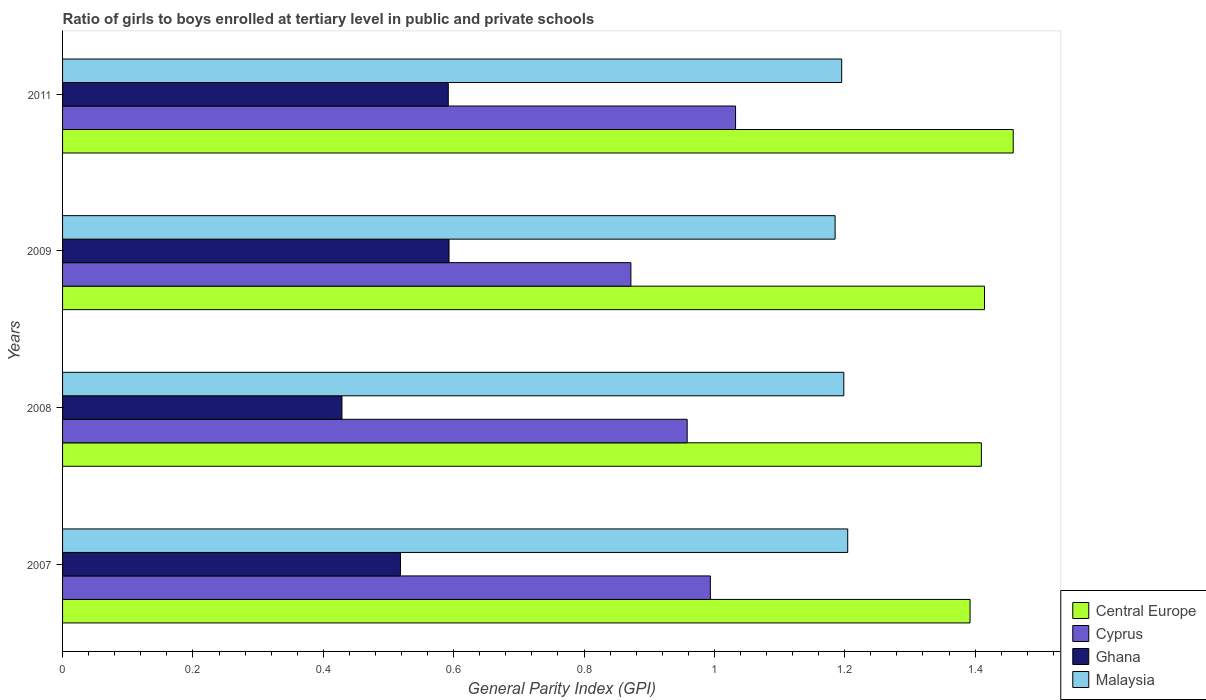How many different coloured bars are there?
Give a very brief answer. 4. How many groups of bars are there?
Offer a very short reply. 4. Are the number of bars per tick equal to the number of legend labels?
Your response must be concise. Yes. In how many cases, is the number of bars for a given year not equal to the number of legend labels?
Provide a short and direct response. 0. What is the general parity index in Ghana in 2009?
Provide a short and direct response. 0.59. Across all years, what is the maximum general parity index in Cyprus?
Provide a short and direct response. 1.03. Across all years, what is the minimum general parity index in Central Europe?
Provide a short and direct response. 1.39. What is the total general parity index in Malaysia in the graph?
Your answer should be compact. 4.78. What is the difference between the general parity index in Ghana in 2007 and that in 2009?
Your response must be concise. -0.07. What is the difference between the general parity index in Central Europe in 2009 and the general parity index in Malaysia in 2007?
Provide a short and direct response. 0.21. What is the average general parity index in Malaysia per year?
Keep it short and to the point. 1.2. In the year 2008, what is the difference between the general parity index in Cyprus and general parity index in Central Europe?
Make the answer very short. -0.45. In how many years, is the general parity index in Cyprus greater than 0.12 ?
Ensure brevity in your answer.  4. What is the ratio of the general parity index in Malaysia in 2007 to that in 2011?
Give a very brief answer. 1.01. What is the difference between the highest and the second highest general parity index in Central Europe?
Offer a very short reply. 0.04. What is the difference between the highest and the lowest general parity index in Cyprus?
Provide a short and direct response. 0.16. Is the sum of the general parity index in Malaysia in 2008 and 2011 greater than the maximum general parity index in Central Europe across all years?
Your answer should be very brief. Yes. What does the 4th bar from the top in 2008 represents?
Your answer should be very brief. Central Europe. What does the 4th bar from the bottom in 2009 represents?
Ensure brevity in your answer.  Malaysia. Is it the case that in every year, the sum of the general parity index in Ghana and general parity index in Malaysia is greater than the general parity index in Cyprus?
Your response must be concise. Yes. How many bars are there?
Your answer should be very brief. 16. Are all the bars in the graph horizontal?
Your answer should be very brief. Yes. How many years are there in the graph?
Offer a very short reply. 4. What is the difference between two consecutive major ticks on the X-axis?
Give a very brief answer. 0.2. Are the values on the major ticks of X-axis written in scientific E-notation?
Your answer should be compact. No. Where does the legend appear in the graph?
Your response must be concise. Bottom right. How many legend labels are there?
Provide a short and direct response. 4. What is the title of the graph?
Your answer should be compact. Ratio of girls to boys enrolled at tertiary level in public and private schools. What is the label or title of the X-axis?
Provide a succinct answer. General Parity Index (GPI). What is the label or title of the Y-axis?
Your answer should be very brief. Years. What is the General Parity Index (GPI) in Central Europe in 2007?
Make the answer very short. 1.39. What is the General Parity Index (GPI) in Cyprus in 2007?
Give a very brief answer. 0.99. What is the General Parity Index (GPI) in Ghana in 2007?
Offer a very short reply. 0.52. What is the General Parity Index (GPI) of Malaysia in 2007?
Give a very brief answer. 1.2. What is the General Parity Index (GPI) in Central Europe in 2008?
Provide a succinct answer. 1.41. What is the General Parity Index (GPI) of Cyprus in 2008?
Your response must be concise. 0.96. What is the General Parity Index (GPI) of Ghana in 2008?
Your answer should be very brief. 0.43. What is the General Parity Index (GPI) in Malaysia in 2008?
Your answer should be very brief. 1.2. What is the General Parity Index (GPI) of Central Europe in 2009?
Ensure brevity in your answer.  1.41. What is the General Parity Index (GPI) of Cyprus in 2009?
Keep it short and to the point. 0.87. What is the General Parity Index (GPI) of Ghana in 2009?
Offer a terse response. 0.59. What is the General Parity Index (GPI) of Malaysia in 2009?
Your answer should be very brief. 1.19. What is the General Parity Index (GPI) of Central Europe in 2011?
Provide a short and direct response. 1.46. What is the General Parity Index (GPI) in Cyprus in 2011?
Give a very brief answer. 1.03. What is the General Parity Index (GPI) in Ghana in 2011?
Give a very brief answer. 0.59. What is the General Parity Index (GPI) in Malaysia in 2011?
Provide a short and direct response. 1.2. Across all years, what is the maximum General Parity Index (GPI) in Central Europe?
Offer a very short reply. 1.46. Across all years, what is the maximum General Parity Index (GPI) of Cyprus?
Make the answer very short. 1.03. Across all years, what is the maximum General Parity Index (GPI) of Ghana?
Provide a short and direct response. 0.59. Across all years, what is the maximum General Parity Index (GPI) in Malaysia?
Your answer should be very brief. 1.2. Across all years, what is the minimum General Parity Index (GPI) in Central Europe?
Offer a terse response. 1.39. Across all years, what is the minimum General Parity Index (GPI) of Cyprus?
Your response must be concise. 0.87. Across all years, what is the minimum General Parity Index (GPI) in Ghana?
Provide a short and direct response. 0.43. Across all years, what is the minimum General Parity Index (GPI) in Malaysia?
Make the answer very short. 1.19. What is the total General Parity Index (GPI) in Central Europe in the graph?
Provide a succinct answer. 5.67. What is the total General Parity Index (GPI) in Cyprus in the graph?
Your response must be concise. 3.86. What is the total General Parity Index (GPI) of Ghana in the graph?
Make the answer very short. 2.13. What is the total General Parity Index (GPI) in Malaysia in the graph?
Keep it short and to the point. 4.78. What is the difference between the General Parity Index (GPI) in Central Europe in 2007 and that in 2008?
Your answer should be compact. -0.02. What is the difference between the General Parity Index (GPI) of Cyprus in 2007 and that in 2008?
Offer a terse response. 0.04. What is the difference between the General Parity Index (GPI) in Ghana in 2007 and that in 2008?
Make the answer very short. 0.09. What is the difference between the General Parity Index (GPI) of Malaysia in 2007 and that in 2008?
Offer a terse response. 0.01. What is the difference between the General Parity Index (GPI) of Central Europe in 2007 and that in 2009?
Offer a terse response. -0.02. What is the difference between the General Parity Index (GPI) in Cyprus in 2007 and that in 2009?
Offer a very short reply. 0.12. What is the difference between the General Parity Index (GPI) in Ghana in 2007 and that in 2009?
Your answer should be very brief. -0.07. What is the difference between the General Parity Index (GPI) in Malaysia in 2007 and that in 2009?
Provide a short and direct response. 0.02. What is the difference between the General Parity Index (GPI) in Central Europe in 2007 and that in 2011?
Ensure brevity in your answer.  -0.07. What is the difference between the General Parity Index (GPI) of Cyprus in 2007 and that in 2011?
Your response must be concise. -0.04. What is the difference between the General Parity Index (GPI) in Ghana in 2007 and that in 2011?
Your answer should be very brief. -0.07. What is the difference between the General Parity Index (GPI) in Malaysia in 2007 and that in 2011?
Offer a terse response. 0.01. What is the difference between the General Parity Index (GPI) in Central Europe in 2008 and that in 2009?
Keep it short and to the point. -0. What is the difference between the General Parity Index (GPI) in Cyprus in 2008 and that in 2009?
Your answer should be compact. 0.09. What is the difference between the General Parity Index (GPI) of Ghana in 2008 and that in 2009?
Offer a very short reply. -0.16. What is the difference between the General Parity Index (GPI) of Malaysia in 2008 and that in 2009?
Offer a terse response. 0.01. What is the difference between the General Parity Index (GPI) of Central Europe in 2008 and that in 2011?
Offer a very short reply. -0.05. What is the difference between the General Parity Index (GPI) of Cyprus in 2008 and that in 2011?
Your answer should be very brief. -0.07. What is the difference between the General Parity Index (GPI) in Ghana in 2008 and that in 2011?
Offer a terse response. -0.16. What is the difference between the General Parity Index (GPI) in Malaysia in 2008 and that in 2011?
Your answer should be compact. 0. What is the difference between the General Parity Index (GPI) in Central Europe in 2009 and that in 2011?
Provide a short and direct response. -0.04. What is the difference between the General Parity Index (GPI) in Cyprus in 2009 and that in 2011?
Give a very brief answer. -0.16. What is the difference between the General Parity Index (GPI) of Ghana in 2009 and that in 2011?
Ensure brevity in your answer.  0. What is the difference between the General Parity Index (GPI) of Malaysia in 2009 and that in 2011?
Your answer should be very brief. -0.01. What is the difference between the General Parity Index (GPI) of Central Europe in 2007 and the General Parity Index (GPI) of Cyprus in 2008?
Make the answer very short. 0.43. What is the difference between the General Parity Index (GPI) in Central Europe in 2007 and the General Parity Index (GPI) in Ghana in 2008?
Ensure brevity in your answer.  0.96. What is the difference between the General Parity Index (GPI) of Central Europe in 2007 and the General Parity Index (GPI) of Malaysia in 2008?
Ensure brevity in your answer.  0.19. What is the difference between the General Parity Index (GPI) in Cyprus in 2007 and the General Parity Index (GPI) in Ghana in 2008?
Your answer should be compact. 0.57. What is the difference between the General Parity Index (GPI) of Cyprus in 2007 and the General Parity Index (GPI) of Malaysia in 2008?
Ensure brevity in your answer.  -0.2. What is the difference between the General Parity Index (GPI) in Ghana in 2007 and the General Parity Index (GPI) in Malaysia in 2008?
Offer a very short reply. -0.68. What is the difference between the General Parity Index (GPI) of Central Europe in 2007 and the General Parity Index (GPI) of Cyprus in 2009?
Provide a succinct answer. 0.52. What is the difference between the General Parity Index (GPI) of Central Europe in 2007 and the General Parity Index (GPI) of Ghana in 2009?
Make the answer very short. 0.8. What is the difference between the General Parity Index (GPI) in Central Europe in 2007 and the General Parity Index (GPI) in Malaysia in 2009?
Offer a terse response. 0.21. What is the difference between the General Parity Index (GPI) of Cyprus in 2007 and the General Parity Index (GPI) of Ghana in 2009?
Your response must be concise. 0.4. What is the difference between the General Parity Index (GPI) in Cyprus in 2007 and the General Parity Index (GPI) in Malaysia in 2009?
Offer a very short reply. -0.19. What is the difference between the General Parity Index (GPI) of Ghana in 2007 and the General Parity Index (GPI) of Malaysia in 2009?
Provide a succinct answer. -0.67. What is the difference between the General Parity Index (GPI) in Central Europe in 2007 and the General Parity Index (GPI) in Cyprus in 2011?
Offer a very short reply. 0.36. What is the difference between the General Parity Index (GPI) of Central Europe in 2007 and the General Parity Index (GPI) of Ghana in 2011?
Offer a terse response. 0.8. What is the difference between the General Parity Index (GPI) of Central Europe in 2007 and the General Parity Index (GPI) of Malaysia in 2011?
Provide a short and direct response. 0.2. What is the difference between the General Parity Index (GPI) of Cyprus in 2007 and the General Parity Index (GPI) of Ghana in 2011?
Give a very brief answer. 0.4. What is the difference between the General Parity Index (GPI) in Cyprus in 2007 and the General Parity Index (GPI) in Malaysia in 2011?
Your response must be concise. -0.2. What is the difference between the General Parity Index (GPI) in Ghana in 2007 and the General Parity Index (GPI) in Malaysia in 2011?
Provide a short and direct response. -0.68. What is the difference between the General Parity Index (GPI) of Central Europe in 2008 and the General Parity Index (GPI) of Cyprus in 2009?
Ensure brevity in your answer.  0.54. What is the difference between the General Parity Index (GPI) of Central Europe in 2008 and the General Parity Index (GPI) of Ghana in 2009?
Ensure brevity in your answer.  0.82. What is the difference between the General Parity Index (GPI) of Central Europe in 2008 and the General Parity Index (GPI) of Malaysia in 2009?
Keep it short and to the point. 0.22. What is the difference between the General Parity Index (GPI) in Cyprus in 2008 and the General Parity Index (GPI) in Ghana in 2009?
Offer a very short reply. 0.37. What is the difference between the General Parity Index (GPI) of Cyprus in 2008 and the General Parity Index (GPI) of Malaysia in 2009?
Give a very brief answer. -0.23. What is the difference between the General Parity Index (GPI) of Ghana in 2008 and the General Parity Index (GPI) of Malaysia in 2009?
Provide a short and direct response. -0.76. What is the difference between the General Parity Index (GPI) of Central Europe in 2008 and the General Parity Index (GPI) of Cyprus in 2011?
Make the answer very short. 0.38. What is the difference between the General Parity Index (GPI) of Central Europe in 2008 and the General Parity Index (GPI) of Ghana in 2011?
Your response must be concise. 0.82. What is the difference between the General Parity Index (GPI) of Central Europe in 2008 and the General Parity Index (GPI) of Malaysia in 2011?
Offer a very short reply. 0.21. What is the difference between the General Parity Index (GPI) in Cyprus in 2008 and the General Parity Index (GPI) in Ghana in 2011?
Offer a very short reply. 0.37. What is the difference between the General Parity Index (GPI) of Cyprus in 2008 and the General Parity Index (GPI) of Malaysia in 2011?
Keep it short and to the point. -0.24. What is the difference between the General Parity Index (GPI) in Ghana in 2008 and the General Parity Index (GPI) in Malaysia in 2011?
Provide a short and direct response. -0.77. What is the difference between the General Parity Index (GPI) of Central Europe in 2009 and the General Parity Index (GPI) of Cyprus in 2011?
Keep it short and to the point. 0.38. What is the difference between the General Parity Index (GPI) in Central Europe in 2009 and the General Parity Index (GPI) in Ghana in 2011?
Give a very brief answer. 0.82. What is the difference between the General Parity Index (GPI) in Central Europe in 2009 and the General Parity Index (GPI) in Malaysia in 2011?
Keep it short and to the point. 0.22. What is the difference between the General Parity Index (GPI) of Cyprus in 2009 and the General Parity Index (GPI) of Ghana in 2011?
Provide a succinct answer. 0.28. What is the difference between the General Parity Index (GPI) in Cyprus in 2009 and the General Parity Index (GPI) in Malaysia in 2011?
Offer a terse response. -0.32. What is the difference between the General Parity Index (GPI) of Ghana in 2009 and the General Parity Index (GPI) of Malaysia in 2011?
Provide a succinct answer. -0.6. What is the average General Parity Index (GPI) in Central Europe per year?
Keep it short and to the point. 1.42. What is the average General Parity Index (GPI) of Cyprus per year?
Your answer should be very brief. 0.96. What is the average General Parity Index (GPI) in Ghana per year?
Provide a short and direct response. 0.53. What is the average General Parity Index (GPI) in Malaysia per year?
Your response must be concise. 1.2. In the year 2007, what is the difference between the General Parity Index (GPI) of Central Europe and General Parity Index (GPI) of Cyprus?
Your response must be concise. 0.4. In the year 2007, what is the difference between the General Parity Index (GPI) of Central Europe and General Parity Index (GPI) of Ghana?
Make the answer very short. 0.87. In the year 2007, what is the difference between the General Parity Index (GPI) in Central Europe and General Parity Index (GPI) in Malaysia?
Ensure brevity in your answer.  0.19. In the year 2007, what is the difference between the General Parity Index (GPI) in Cyprus and General Parity Index (GPI) in Ghana?
Give a very brief answer. 0.48. In the year 2007, what is the difference between the General Parity Index (GPI) in Cyprus and General Parity Index (GPI) in Malaysia?
Keep it short and to the point. -0.21. In the year 2007, what is the difference between the General Parity Index (GPI) in Ghana and General Parity Index (GPI) in Malaysia?
Provide a succinct answer. -0.69. In the year 2008, what is the difference between the General Parity Index (GPI) of Central Europe and General Parity Index (GPI) of Cyprus?
Your response must be concise. 0.45. In the year 2008, what is the difference between the General Parity Index (GPI) of Central Europe and General Parity Index (GPI) of Ghana?
Keep it short and to the point. 0.98. In the year 2008, what is the difference between the General Parity Index (GPI) of Central Europe and General Parity Index (GPI) of Malaysia?
Your answer should be compact. 0.21. In the year 2008, what is the difference between the General Parity Index (GPI) in Cyprus and General Parity Index (GPI) in Ghana?
Ensure brevity in your answer.  0.53. In the year 2008, what is the difference between the General Parity Index (GPI) in Cyprus and General Parity Index (GPI) in Malaysia?
Keep it short and to the point. -0.24. In the year 2008, what is the difference between the General Parity Index (GPI) in Ghana and General Parity Index (GPI) in Malaysia?
Make the answer very short. -0.77. In the year 2009, what is the difference between the General Parity Index (GPI) of Central Europe and General Parity Index (GPI) of Cyprus?
Provide a short and direct response. 0.54. In the year 2009, what is the difference between the General Parity Index (GPI) in Central Europe and General Parity Index (GPI) in Ghana?
Your answer should be very brief. 0.82. In the year 2009, what is the difference between the General Parity Index (GPI) of Central Europe and General Parity Index (GPI) of Malaysia?
Offer a terse response. 0.23. In the year 2009, what is the difference between the General Parity Index (GPI) in Cyprus and General Parity Index (GPI) in Ghana?
Make the answer very short. 0.28. In the year 2009, what is the difference between the General Parity Index (GPI) of Cyprus and General Parity Index (GPI) of Malaysia?
Keep it short and to the point. -0.31. In the year 2009, what is the difference between the General Parity Index (GPI) in Ghana and General Parity Index (GPI) in Malaysia?
Ensure brevity in your answer.  -0.59. In the year 2011, what is the difference between the General Parity Index (GPI) in Central Europe and General Parity Index (GPI) in Cyprus?
Ensure brevity in your answer.  0.43. In the year 2011, what is the difference between the General Parity Index (GPI) of Central Europe and General Parity Index (GPI) of Ghana?
Offer a very short reply. 0.87. In the year 2011, what is the difference between the General Parity Index (GPI) in Central Europe and General Parity Index (GPI) in Malaysia?
Provide a succinct answer. 0.26. In the year 2011, what is the difference between the General Parity Index (GPI) of Cyprus and General Parity Index (GPI) of Ghana?
Provide a succinct answer. 0.44. In the year 2011, what is the difference between the General Parity Index (GPI) of Cyprus and General Parity Index (GPI) of Malaysia?
Your answer should be compact. -0.16. In the year 2011, what is the difference between the General Parity Index (GPI) of Ghana and General Parity Index (GPI) of Malaysia?
Provide a succinct answer. -0.6. What is the ratio of the General Parity Index (GPI) in Cyprus in 2007 to that in 2008?
Your answer should be very brief. 1.04. What is the ratio of the General Parity Index (GPI) in Ghana in 2007 to that in 2008?
Provide a succinct answer. 1.21. What is the ratio of the General Parity Index (GPI) of Central Europe in 2007 to that in 2009?
Keep it short and to the point. 0.98. What is the ratio of the General Parity Index (GPI) of Cyprus in 2007 to that in 2009?
Keep it short and to the point. 1.14. What is the ratio of the General Parity Index (GPI) of Ghana in 2007 to that in 2009?
Provide a succinct answer. 0.87. What is the ratio of the General Parity Index (GPI) of Malaysia in 2007 to that in 2009?
Your response must be concise. 1.02. What is the ratio of the General Parity Index (GPI) in Central Europe in 2007 to that in 2011?
Offer a terse response. 0.95. What is the ratio of the General Parity Index (GPI) in Cyprus in 2007 to that in 2011?
Your answer should be very brief. 0.96. What is the ratio of the General Parity Index (GPI) of Ghana in 2007 to that in 2011?
Provide a short and direct response. 0.88. What is the ratio of the General Parity Index (GPI) in Malaysia in 2007 to that in 2011?
Keep it short and to the point. 1.01. What is the ratio of the General Parity Index (GPI) in Cyprus in 2008 to that in 2009?
Make the answer very short. 1.1. What is the ratio of the General Parity Index (GPI) of Ghana in 2008 to that in 2009?
Your response must be concise. 0.72. What is the ratio of the General Parity Index (GPI) of Malaysia in 2008 to that in 2009?
Your answer should be compact. 1.01. What is the ratio of the General Parity Index (GPI) of Central Europe in 2008 to that in 2011?
Your response must be concise. 0.97. What is the ratio of the General Parity Index (GPI) in Cyprus in 2008 to that in 2011?
Offer a terse response. 0.93. What is the ratio of the General Parity Index (GPI) of Ghana in 2008 to that in 2011?
Your answer should be compact. 0.72. What is the ratio of the General Parity Index (GPI) of Malaysia in 2008 to that in 2011?
Ensure brevity in your answer.  1. What is the ratio of the General Parity Index (GPI) in Central Europe in 2009 to that in 2011?
Your answer should be very brief. 0.97. What is the ratio of the General Parity Index (GPI) in Cyprus in 2009 to that in 2011?
Your response must be concise. 0.84. What is the difference between the highest and the second highest General Parity Index (GPI) of Central Europe?
Offer a terse response. 0.04. What is the difference between the highest and the second highest General Parity Index (GPI) of Cyprus?
Keep it short and to the point. 0.04. What is the difference between the highest and the second highest General Parity Index (GPI) in Ghana?
Ensure brevity in your answer.  0. What is the difference between the highest and the second highest General Parity Index (GPI) in Malaysia?
Your answer should be very brief. 0.01. What is the difference between the highest and the lowest General Parity Index (GPI) in Central Europe?
Your answer should be very brief. 0.07. What is the difference between the highest and the lowest General Parity Index (GPI) in Cyprus?
Offer a terse response. 0.16. What is the difference between the highest and the lowest General Parity Index (GPI) of Ghana?
Make the answer very short. 0.16. What is the difference between the highest and the lowest General Parity Index (GPI) in Malaysia?
Keep it short and to the point. 0.02. 